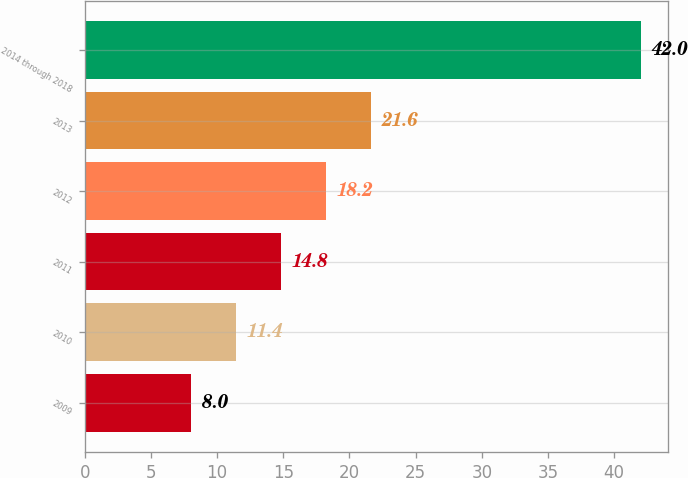Convert chart. <chart><loc_0><loc_0><loc_500><loc_500><bar_chart><fcel>2009<fcel>2010<fcel>2011<fcel>2012<fcel>2013<fcel>2014 through 2018<nl><fcel>8<fcel>11.4<fcel>14.8<fcel>18.2<fcel>21.6<fcel>42<nl></chart> 